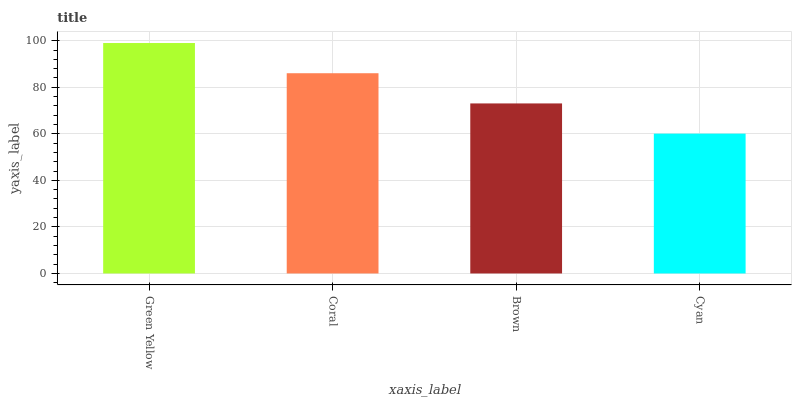Is Cyan the minimum?
Answer yes or no. Yes. Is Green Yellow the maximum?
Answer yes or no. Yes. Is Coral the minimum?
Answer yes or no. No. Is Coral the maximum?
Answer yes or no. No. Is Green Yellow greater than Coral?
Answer yes or no. Yes. Is Coral less than Green Yellow?
Answer yes or no. Yes. Is Coral greater than Green Yellow?
Answer yes or no. No. Is Green Yellow less than Coral?
Answer yes or no. No. Is Coral the high median?
Answer yes or no. Yes. Is Brown the low median?
Answer yes or no. Yes. Is Brown the high median?
Answer yes or no. No. Is Cyan the low median?
Answer yes or no. No. 